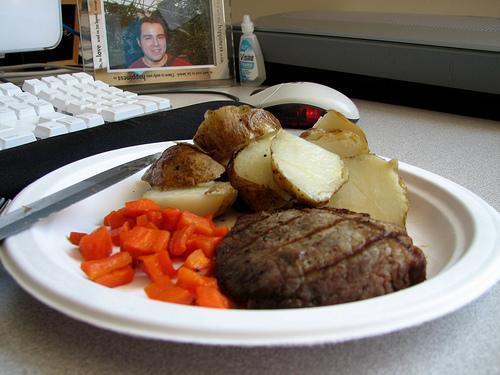Where is this kind of plate normally used?
Choose the correct response, then elucidate: 'Answer: answer
Rationale: rationale.'
Options: Diner, picnic, bar, wedding. Answer: picnic.
Rationale: The plate is made out of paper and is disposable. fancier non-disposable plates are used at diners, bars, and weddings. 